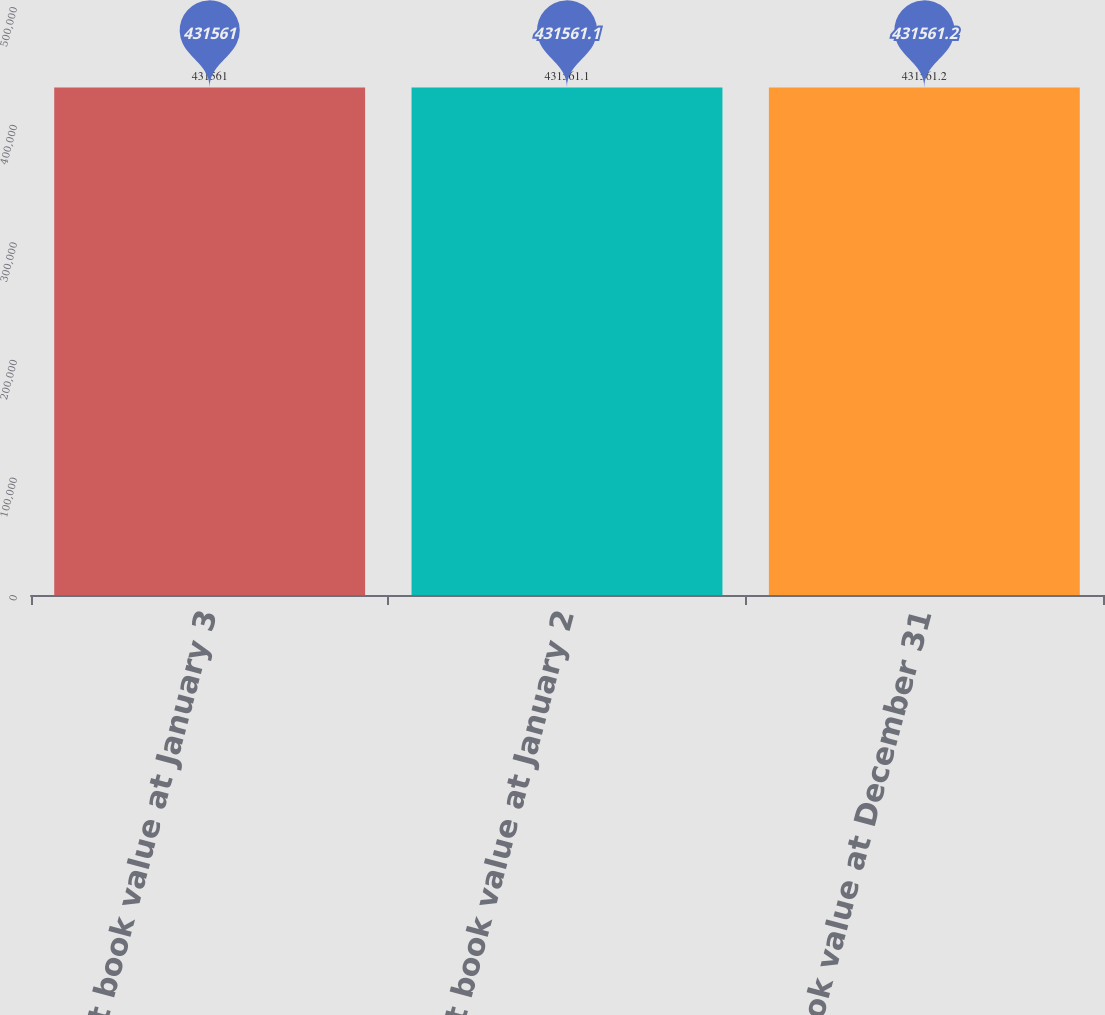Convert chart. <chart><loc_0><loc_0><loc_500><loc_500><bar_chart><fcel>Net book value at January 3<fcel>Net book value at January 2<fcel>Net book value at December 31<nl><fcel>431561<fcel>431561<fcel>431561<nl></chart> 